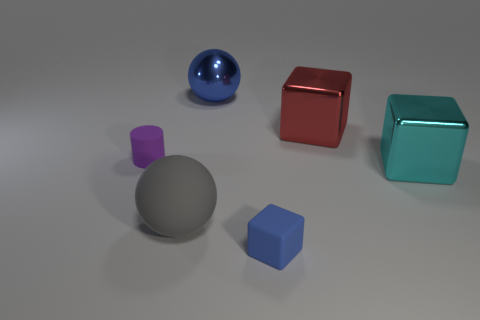Are there any other things that have the same size as the purple matte thing?
Provide a short and direct response. Yes. There is a small rubber thing behind the gray matte ball; what is its shape?
Provide a short and direct response. Cylinder. What number of big matte objects are the same shape as the small purple object?
Give a very brief answer. 0. Are there an equal number of big gray rubber objects in front of the tiny cube and big red things on the left side of the gray thing?
Your answer should be very brief. Yes. Is there a large blue block made of the same material as the cyan object?
Provide a succinct answer. No. Are the red object and the blue cube made of the same material?
Provide a succinct answer. No. What number of gray objects are either large balls or small rubber things?
Your answer should be compact. 1. Are there more tiny blue matte cubes behind the gray matte ball than red metallic objects?
Ensure brevity in your answer.  No. Are there any other rubber cubes that have the same color as the rubber cube?
Offer a very short reply. No. The red metallic block has what size?
Keep it short and to the point. Large. 